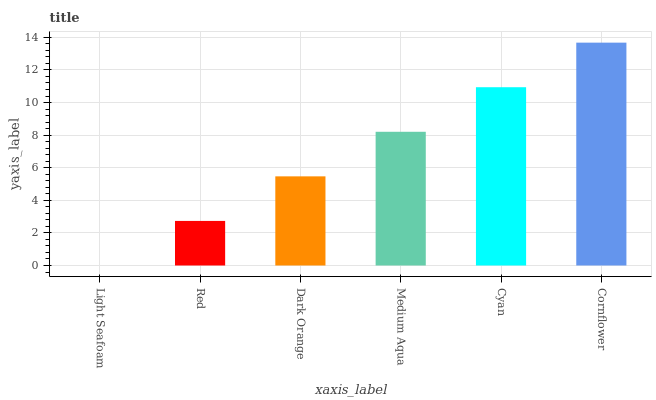Is Red the minimum?
Answer yes or no. No. Is Red the maximum?
Answer yes or no. No. Is Red greater than Light Seafoam?
Answer yes or no. Yes. Is Light Seafoam less than Red?
Answer yes or no. Yes. Is Light Seafoam greater than Red?
Answer yes or no. No. Is Red less than Light Seafoam?
Answer yes or no. No. Is Medium Aqua the high median?
Answer yes or no. Yes. Is Dark Orange the low median?
Answer yes or no. Yes. Is Cornflower the high median?
Answer yes or no. No. Is Light Seafoam the low median?
Answer yes or no. No. 